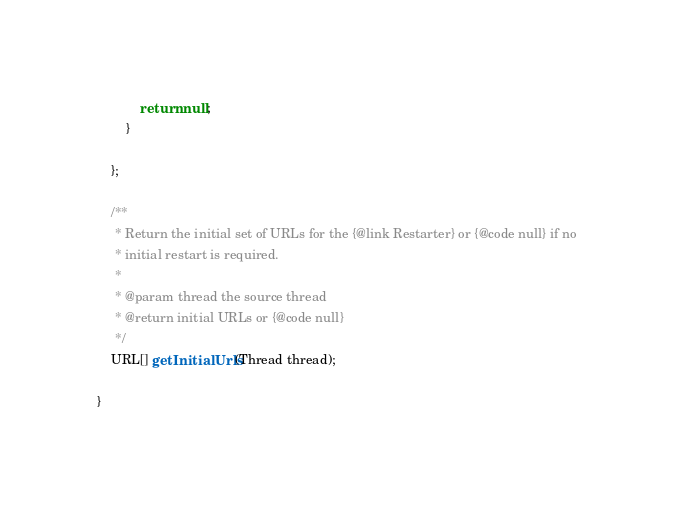Convert code to text. <code><loc_0><loc_0><loc_500><loc_500><_Java_>			return null;
		}

	};

	/**
	 * Return the initial set of URLs for the {@link Restarter} or {@code null} if no
	 * initial restart is required.
	 *
	 * @param thread the source thread
	 * @return initial URLs or {@code null}
	 */
	URL[] getInitialUrls(Thread thread);

}
</code> 